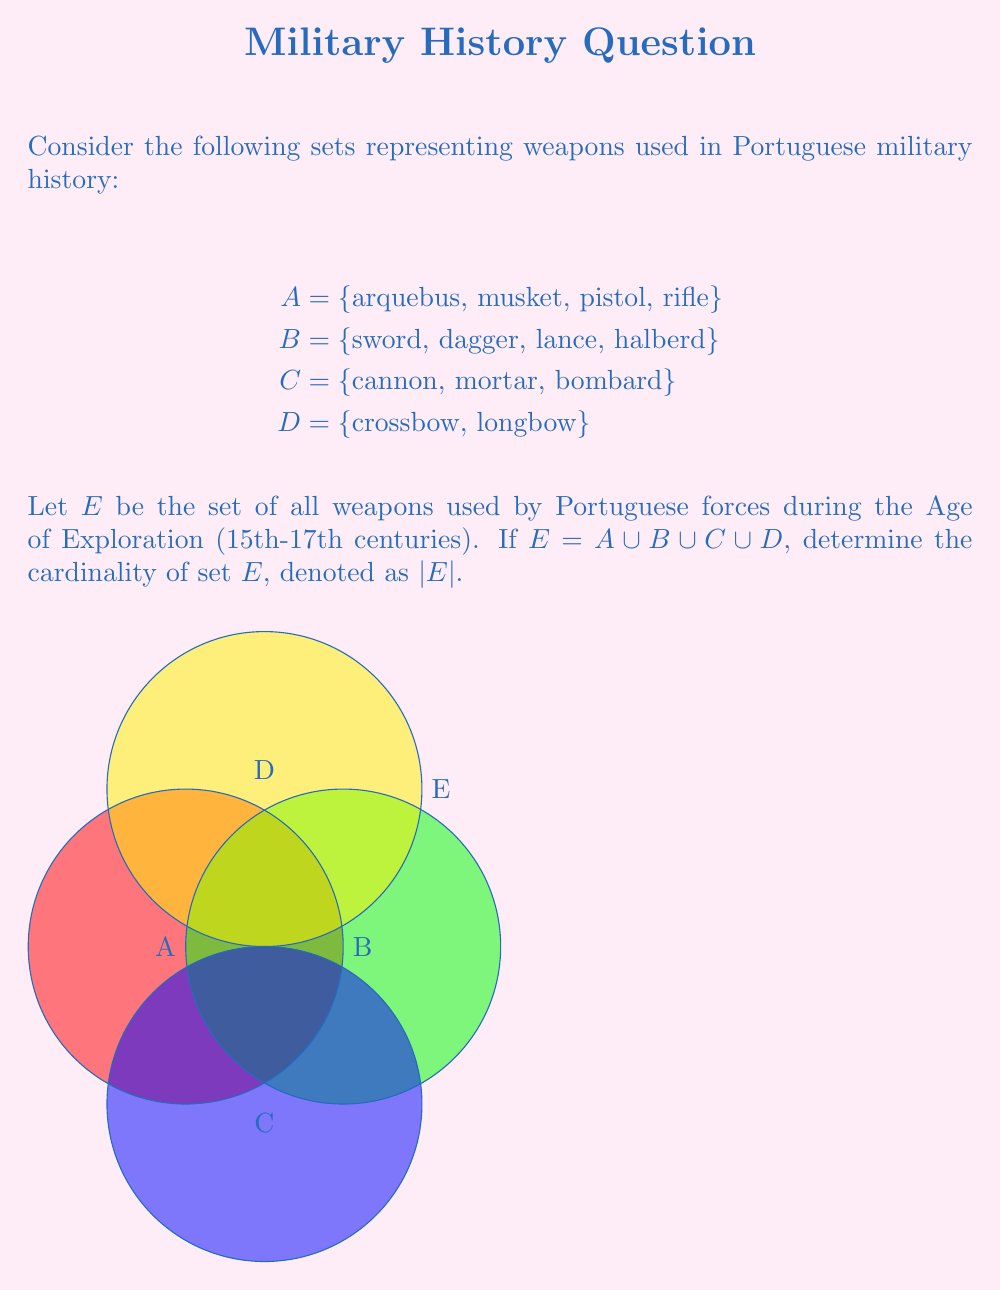Could you help me with this problem? To determine the cardinality of set E, we need to follow these steps:

1) First, let's count the elements in each set:
   |A| = 4
   |B| = 4
   |C| = 3
   |D| = 2

2) Since E is the union of all these sets (E = A ∪ B ∪ C ∪ D), we need to count all unique elements.

3) In this case, there are no overlapping elements between the sets, so we can simply add the cardinalities of each set:

   |E| = |A| + |B| + |C| + |D|

4) Substituting the values:

   |E| = 4 + 4 + 3 + 2

5) Calculating the sum:

   |E| = 13

Therefore, the cardinality of set E, which represents all types of weapons used by Portuguese forces during the Age of Exploration, is 13.
Answer: |E| = 13 